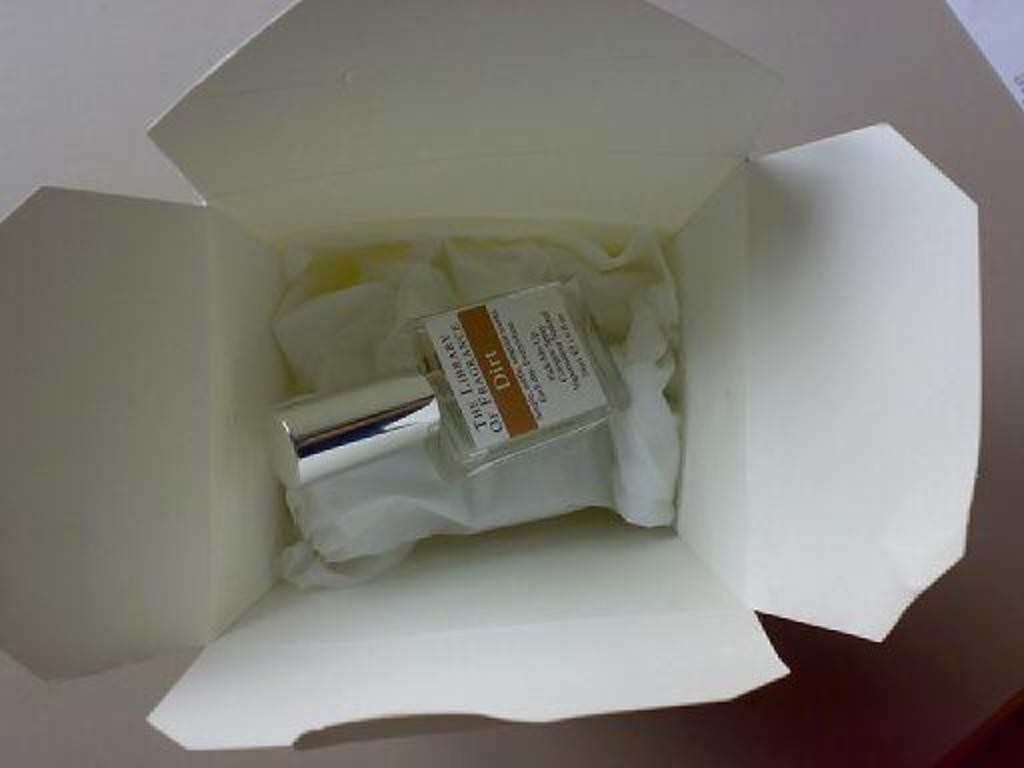What flavor is this perfume?
Provide a short and direct response. Dirt. What does the first line of the bottle say?
Offer a very short reply. The library. 